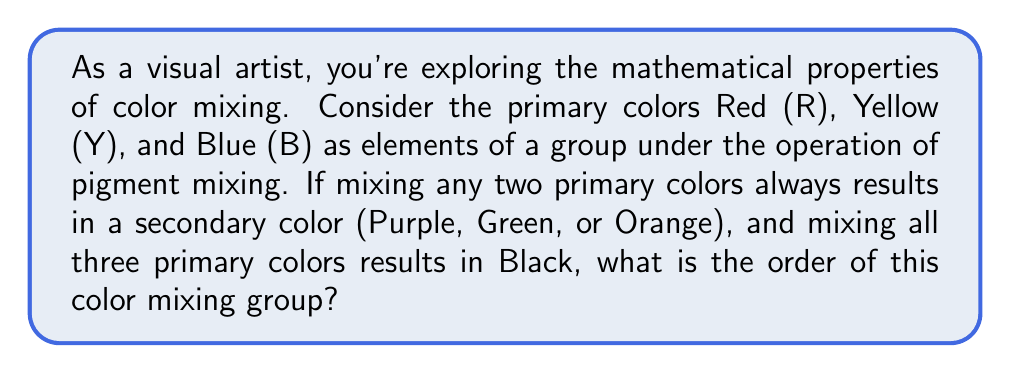Solve this math problem. Let's approach this step-by-step:

1) First, we need to identify all the elements in our group. We have:
   - Primary colors: R, Y, B
   - Secondary colors: Purple (P), Green (G), Orange (O)
   - Black (K)
   - We also need to consider White (W) as the identity element (no color added)

2) Let's define our operation table:

   $$\begin{array}{c|cccccccc}
    * & W & R & Y & B & P & G & O & K \\
    \hline
    W & W & R & Y & B & P & G & O & K \\
    R & R & R & O & P & P & K & O & K \\
    Y & Y & O & Y & G & K & G & O & K \\
    B & B & P & G & B & P & G & K & K \\
    P & P & P & K & P & P & K & K & K \\
    G & G & K & G & G & K & G & K & K \\
    O & O & O & O & K & K & K & O & K \\
    K & K & K & K & K & K & K & K & K
   \end{array}$$

3) To be a group, this operation must satisfy four properties:
   - Closure: The result of mixing any two colors is always in our set.
   - Associativity: $(a * b) * c = a * (b * c)$ for all colors $a$, $b$, and $c$.
   - Identity: White (W) acts as the identity element.
   - Inverse: Each color has an inverse that returns White when mixed.

4) We can verify that all these properties hold for our color mixing operation.

5) The order of a group is the number of elements in the group.

6) Counting the elements in our group: W, R, Y, B, P, G, O, K.

Therefore, we have 8 elements in our color mixing group.
Answer: The order of the color mixing group is 8. 